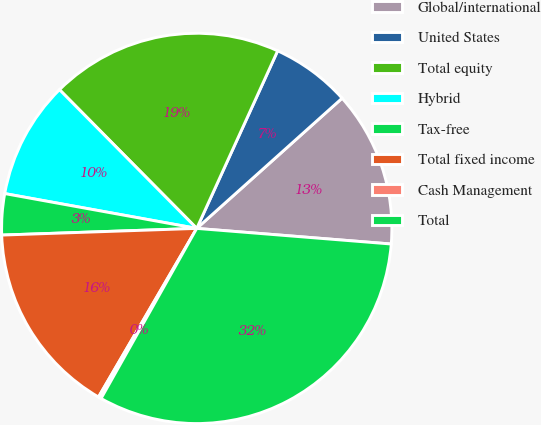Convert chart. <chart><loc_0><loc_0><loc_500><loc_500><pie_chart><fcel>Global/international<fcel>United States<fcel>Total equity<fcel>Hybrid<fcel>Tax-free<fcel>Total fixed income<fcel>Cash Management<fcel>Total<nl><fcel>12.9%<fcel>6.57%<fcel>19.22%<fcel>9.73%<fcel>3.4%<fcel>16.06%<fcel>0.24%<fcel>31.88%<nl></chart> 